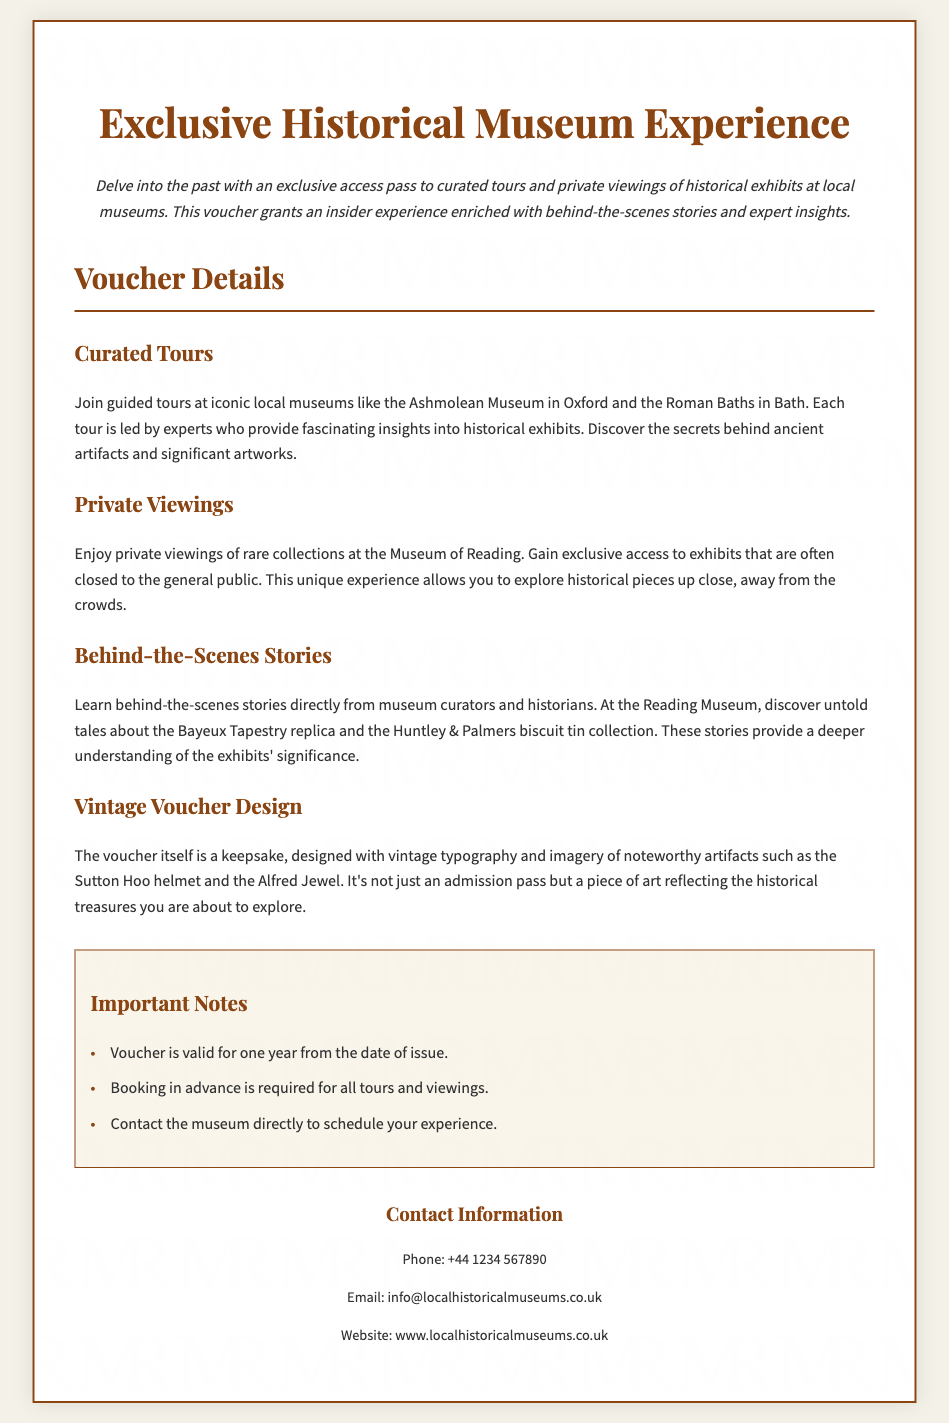What is the title of the voucher? The title of the voucher is presented prominently at the top of the document.
Answer: Exclusive Historical Museum Experience What types of experiences does the voucher offer? The voucher details the experiences included within it, specifically curated tours and private viewings.
Answer: Curated tours and private viewings Where can you join guided tours? The document specifies certain local museums where guided tours are available.
Answer: Ashmolean Museum and Roman Baths Who provides behind-the-scenes stories? The document mentions the people responsible for sharing behind-the-scenes stories during the experience.
Answer: Museum curators and historians What design style is used for the voucher? The document describes the aesthetic quality of the voucher, including typography and imagery.
Answer: Vintage typography and imagery How long is the voucher valid? The document specifies the validity period of the voucher.
Answer: One year What should you do before attending the tours? The document indicates a requirement regarding attendance preparation.
Answer: Booking in advance What artifact is mentioned as part of the voucher design? The document gives an example of a noteworthy artifact featured in the voucher design.
Answer: Sutton Hoo helmet 